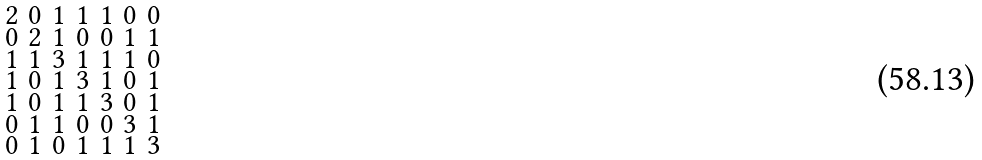Convert formula to latex. <formula><loc_0><loc_0><loc_500><loc_500>\begin{smallmatrix} 2 & 0 & 1 & 1 & 1 & 0 & 0 \\ 0 & 2 & 1 & 0 & 0 & 1 & 1 \\ 1 & 1 & 3 & 1 & 1 & 1 & 0 \\ 1 & 0 & 1 & 3 & 1 & 0 & 1 \\ 1 & 0 & 1 & 1 & 3 & 0 & 1 \\ 0 & 1 & 1 & 0 & 0 & 3 & 1 \\ 0 & 1 & 0 & 1 & 1 & 1 & 3 \end{smallmatrix}</formula> 